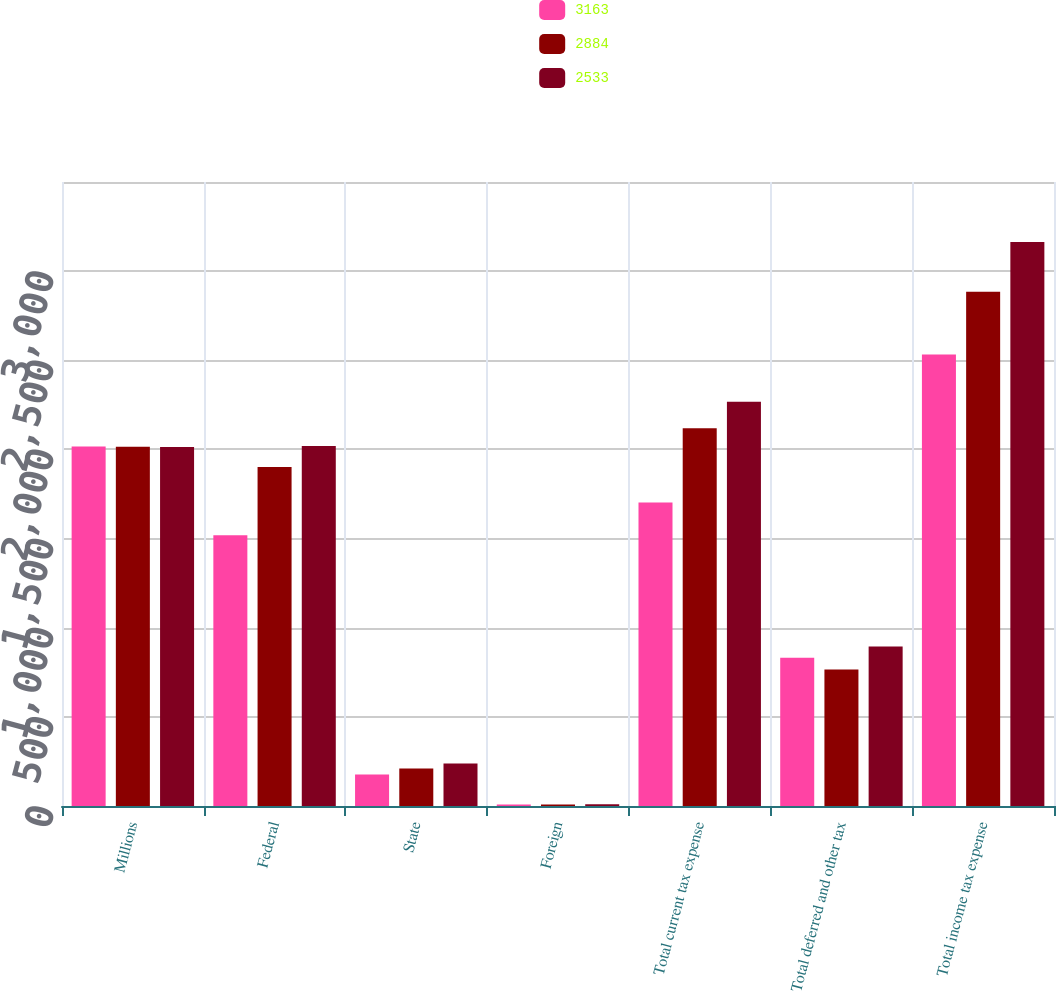Convert chart to OTSL. <chart><loc_0><loc_0><loc_500><loc_500><stacked_bar_chart><ecel><fcel>Millions<fcel>Federal<fcel>State<fcel>Foreign<fcel>Total current tax expense<fcel>Total deferred and other tax<fcel>Total income tax expense<nl><fcel>3163<fcel>2016<fcel>1518<fcel>176<fcel>8<fcel>1702<fcel>831<fcel>2533<nl><fcel>2884<fcel>2015<fcel>1901<fcel>210<fcel>8<fcel>2119<fcel>765<fcel>2884<nl><fcel>2533<fcel>2014<fcel>2019<fcel>239<fcel>10<fcel>2268<fcel>895<fcel>3163<nl></chart> 